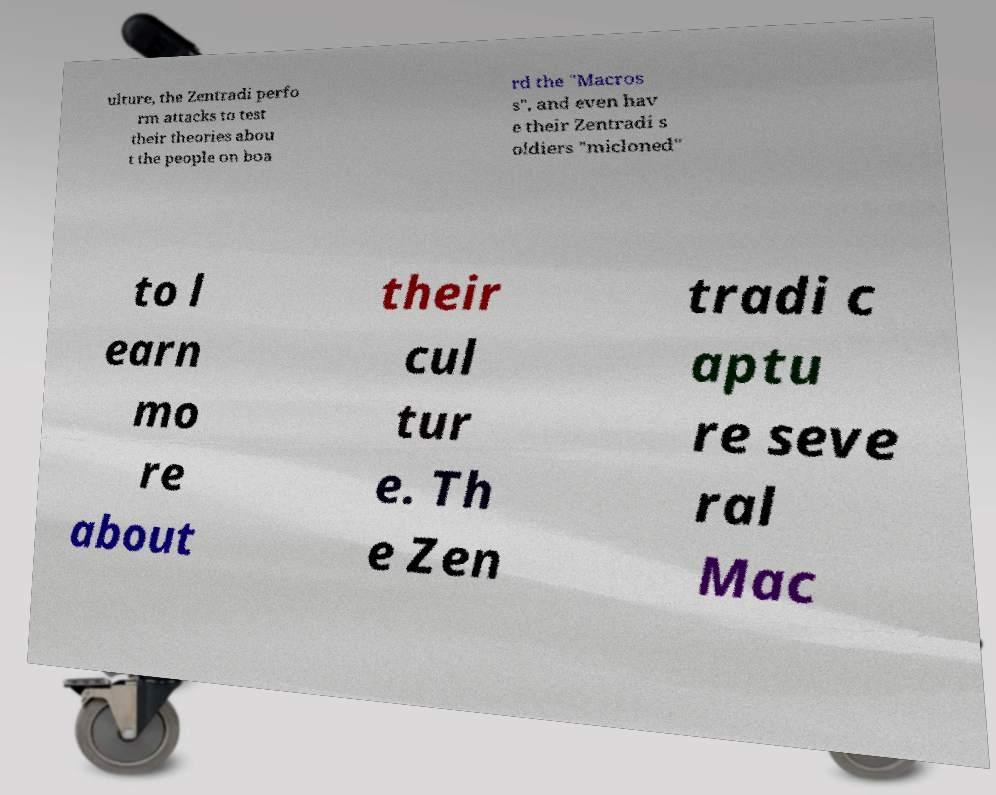Please identify and transcribe the text found in this image. ulture, the Zentradi perfo rm attacks to test their theories abou t the people on boa rd the "Macros s", and even hav e their Zentradi s oldiers "micloned" to l earn mo re about their cul tur e. Th e Zen tradi c aptu re seve ral Mac 